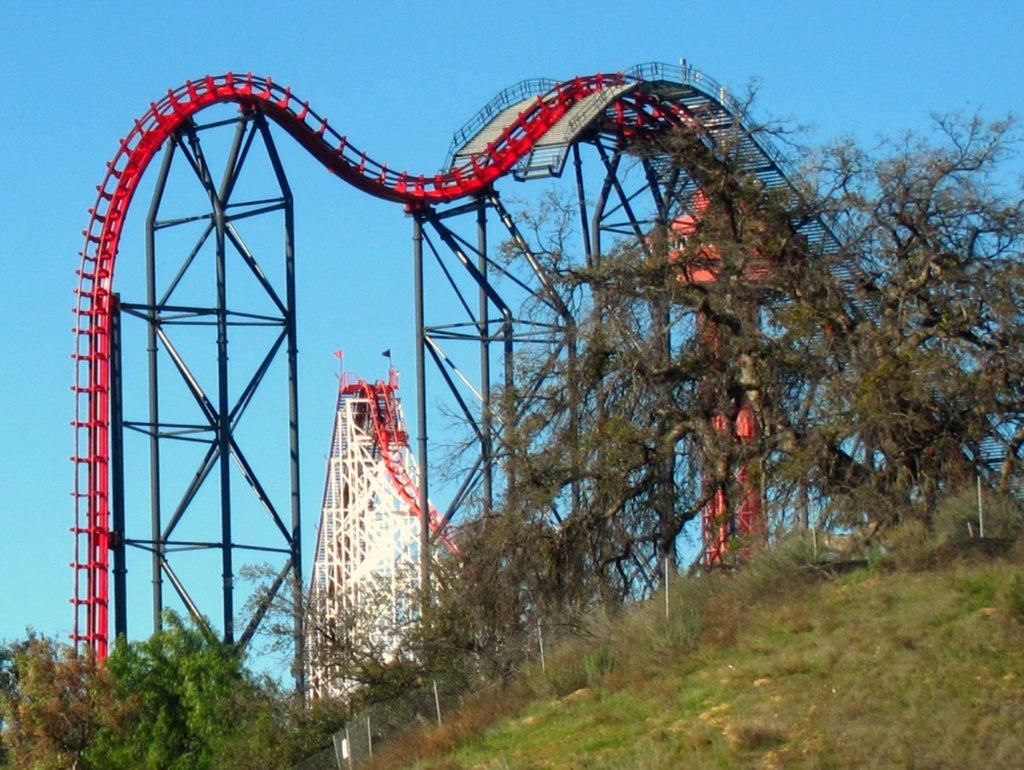What is the main subject of the picture? The main subject of the picture is a rolling coaster. What can be seen at the bottom of the image? Trees, fencing, plants, and grass are visible at the bottom of the image. What is visible at the top of the image? The sky is visible at the top of the image. Can you see a girl holding a quill in the image? There is no girl holding a quill in the image; it features a rolling coaster and elements at the bottom and top of the image. 